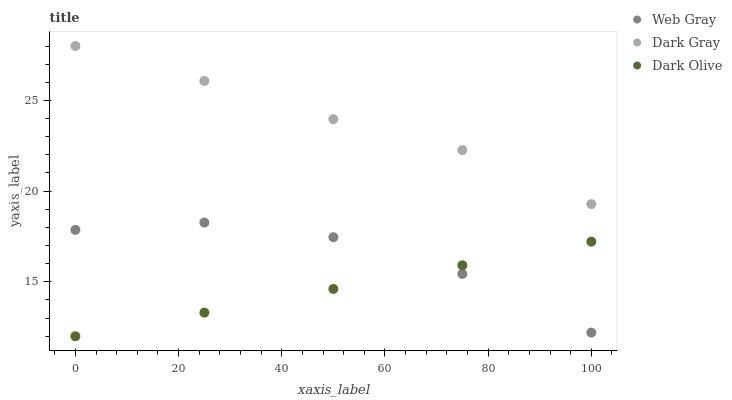Does Dark Olive have the minimum area under the curve?
Answer yes or no. Yes. Does Dark Gray have the maximum area under the curve?
Answer yes or no. Yes. Does Web Gray have the minimum area under the curve?
Answer yes or no. No. Does Web Gray have the maximum area under the curve?
Answer yes or no. No. Is Dark Olive the smoothest?
Answer yes or no. Yes. Is Web Gray the roughest?
Answer yes or no. Yes. Is Web Gray the smoothest?
Answer yes or no. No. Is Dark Olive the roughest?
Answer yes or no. No. Does Dark Olive have the lowest value?
Answer yes or no. Yes. Does Web Gray have the lowest value?
Answer yes or no. No. Does Dark Gray have the highest value?
Answer yes or no. Yes. Does Web Gray have the highest value?
Answer yes or no. No. Is Dark Olive less than Dark Gray?
Answer yes or no. Yes. Is Dark Gray greater than Web Gray?
Answer yes or no. Yes. Does Dark Olive intersect Web Gray?
Answer yes or no. Yes. Is Dark Olive less than Web Gray?
Answer yes or no. No. Is Dark Olive greater than Web Gray?
Answer yes or no. No. Does Dark Olive intersect Dark Gray?
Answer yes or no. No. 